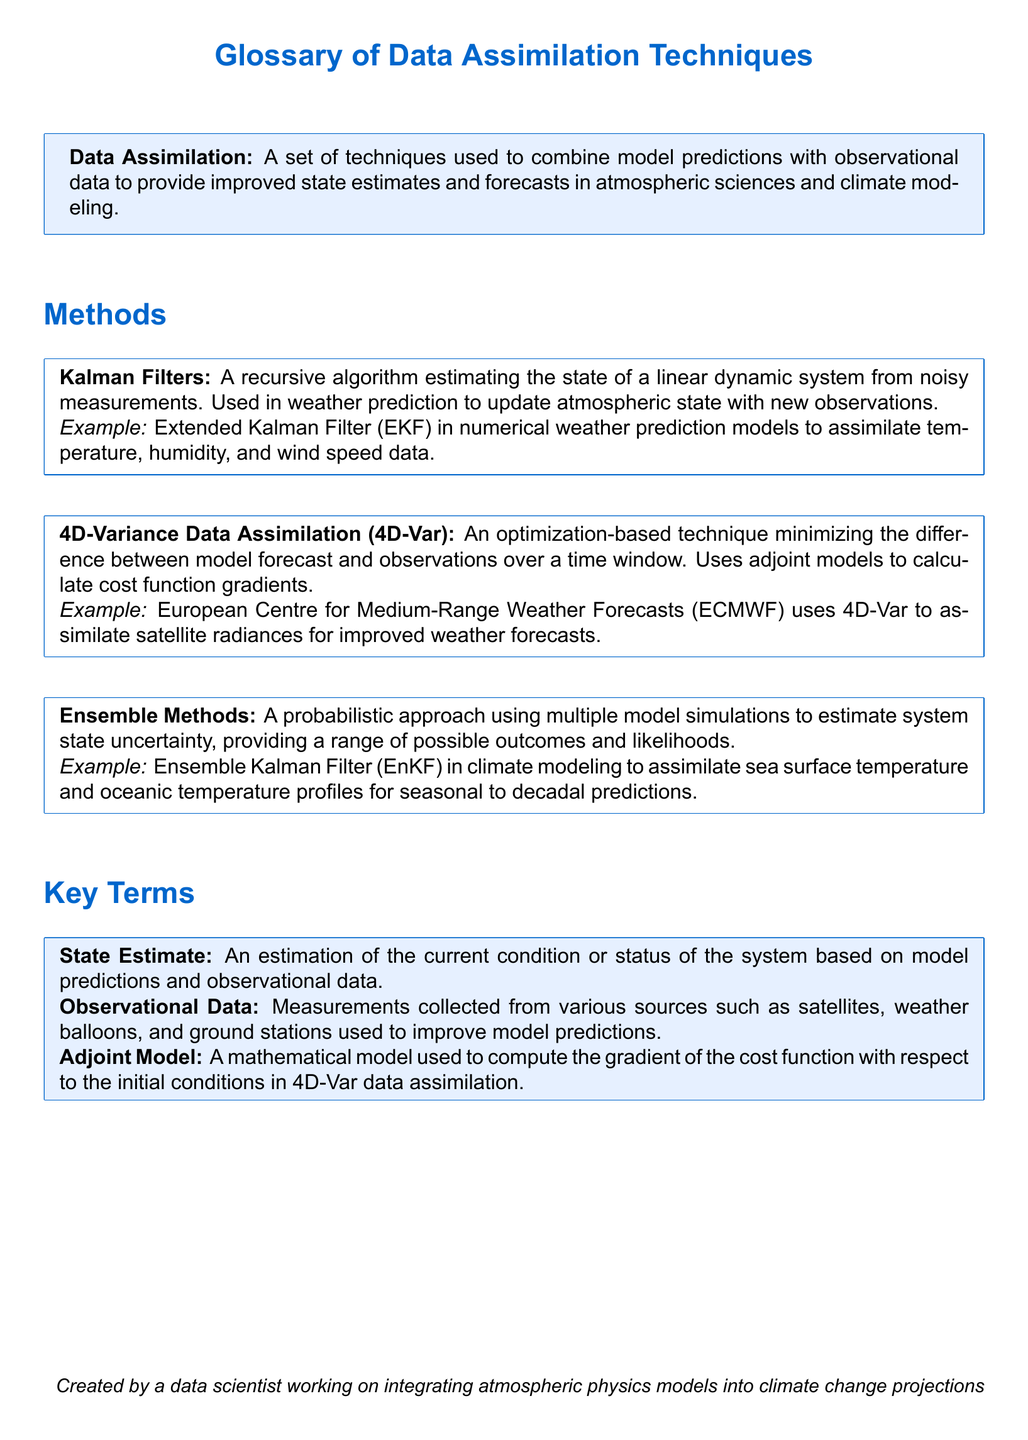What is the main purpose of data assimilation? The main purpose of data assimilation is to combine model predictions with observational data to provide improved state estimates and forecasts in atmospheric sciences and climate modeling.
Answer: To combine model predictions with observational data What is an example of a Kalman Filter used in climate modeling? An example of a Kalman Filter used in climate modeling is the Extended Kalman Filter (EKF) in numerical weather prediction models to assimilate temperature, humidity, and wind speed data.
Answer: Extended Kalman Filter (EKF) What technique uses adjoint models to minimize differences over a time window? The technique that uses adjoint models to minimize differences over a time window is called 4D-Variance Data Assimilation (4D-Var).
Answer: 4D-Variance Data Assimilation (4D-Var) Which organization uses 4D-Var for improved weather forecasts? The European Centre for Medium-Range Weather Forecasts (ECMWF) uses 4D-Var for improved weather forecasts.
Answer: European Centre for Medium-Range Weather Forecasts (ECMWF) What approach do Ensemble Methods utilize in estimating system state uncertainty? Ensemble Methods utilize a probabilistic approach using multiple model simulations to estimate system state uncertainty.
Answer: Probabilistic approach using multiple model simulations What are observational data? Observational data are measurements collected from various sources such as satellites, weather balloons, and ground stations used to improve model predictions.
Answer: Measurements collected from various sources What is the purpose of the adjoint model in data assimilation? The purpose of the adjoint model in data assimilation is to compute the gradient of the cost function with respect to the initial conditions in 4D-Var data assimilation.
Answer: Compute the gradient of the cost function What type of estimates do Ensemble Kalman Filter (EnKF) provide? Ensemble Kalman Filter (EnKF) provides a range of possible outcomes and likelihoods.
Answer: A range of possible outcomes and likelihoods Which type of estimate refers to the current condition of the system? The type of estimate that refers to the current condition of the system is called State Estimate.
Answer: State Estimate 